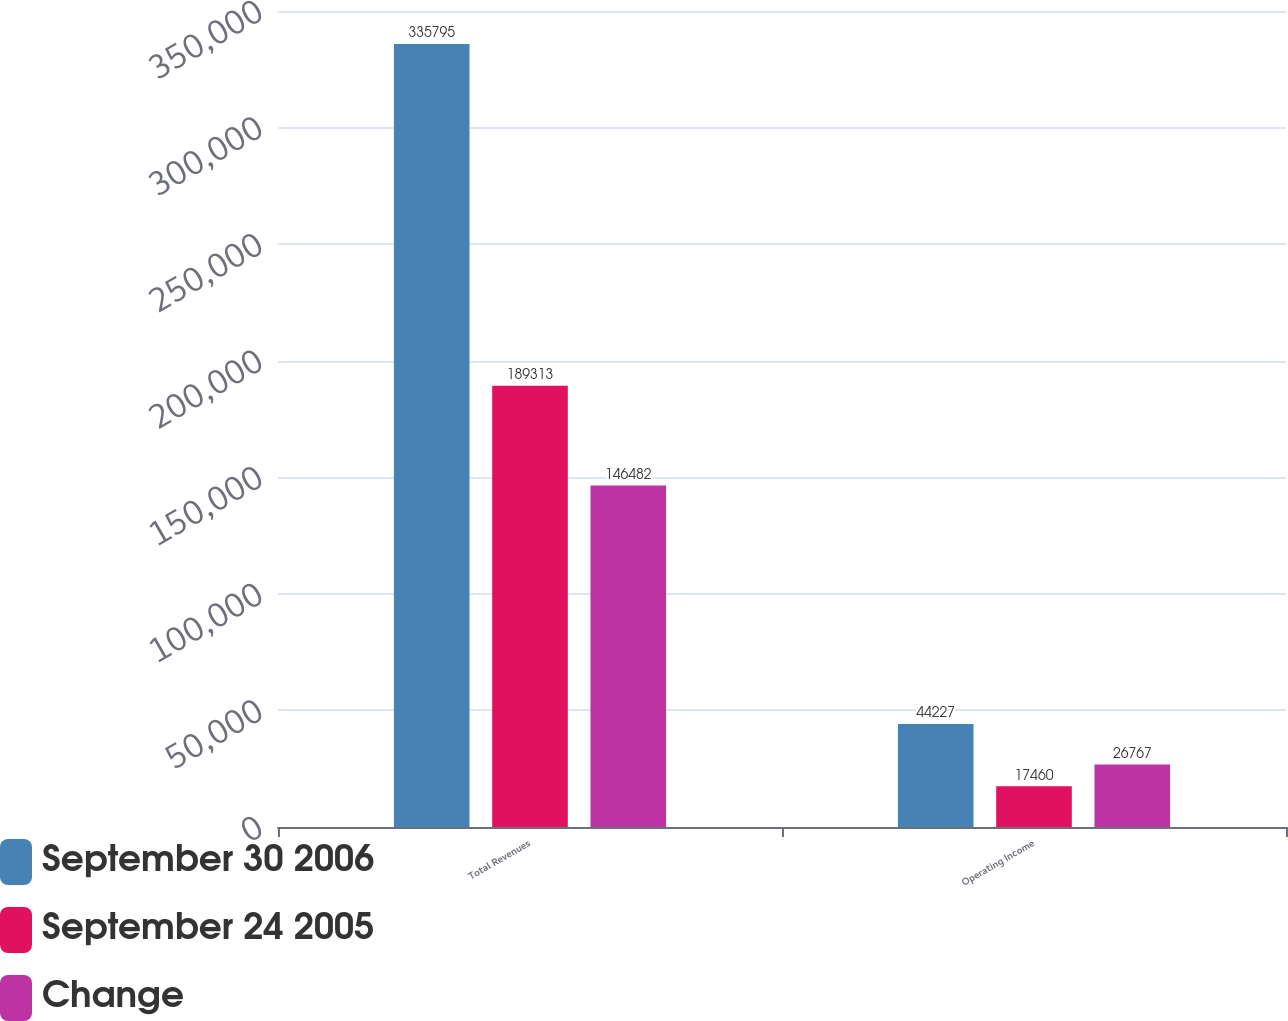<chart> <loc_0><loc_0><loc_500><loc_500><stacked_bar_chart><ecel><fcel>Total Revenues<fcel>Operating Income<nl><fcel>September 30 2006<fcel>335795<fcel>44227<nl><fcel>September 24 2005<fcel>189313<fcel>17460<nl><fcel>Change<fcel>146482<fcel>26767<nl></chart> 